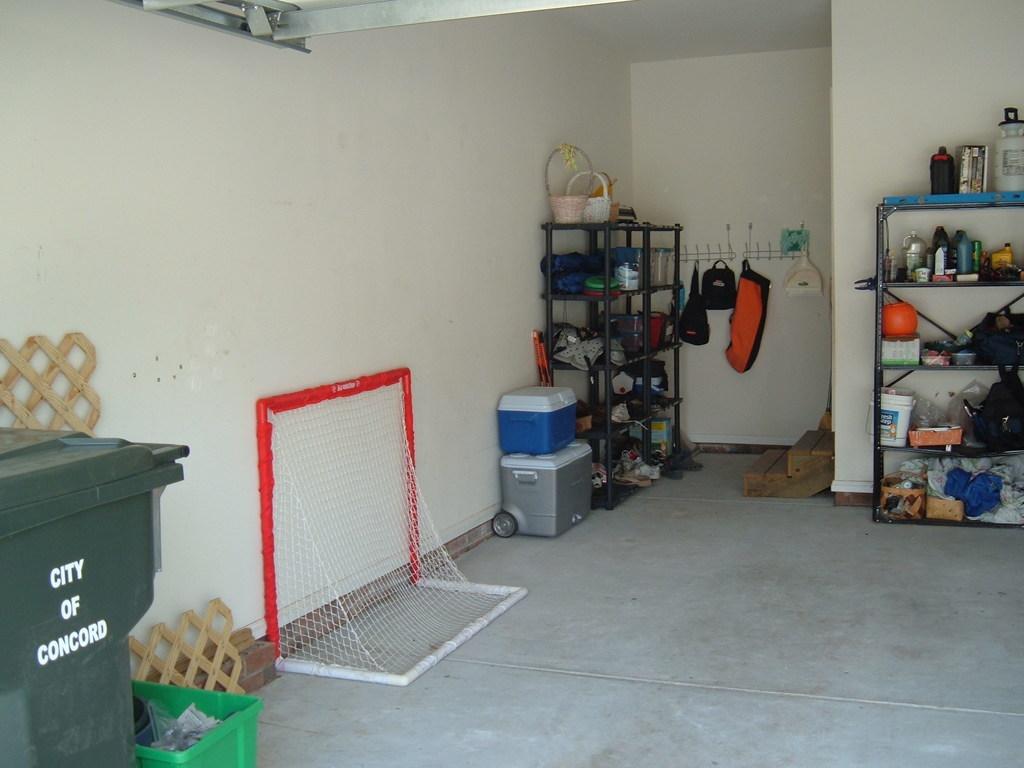Waht city is mentioned on the trash bin?
Make the answer very short. Concord. 